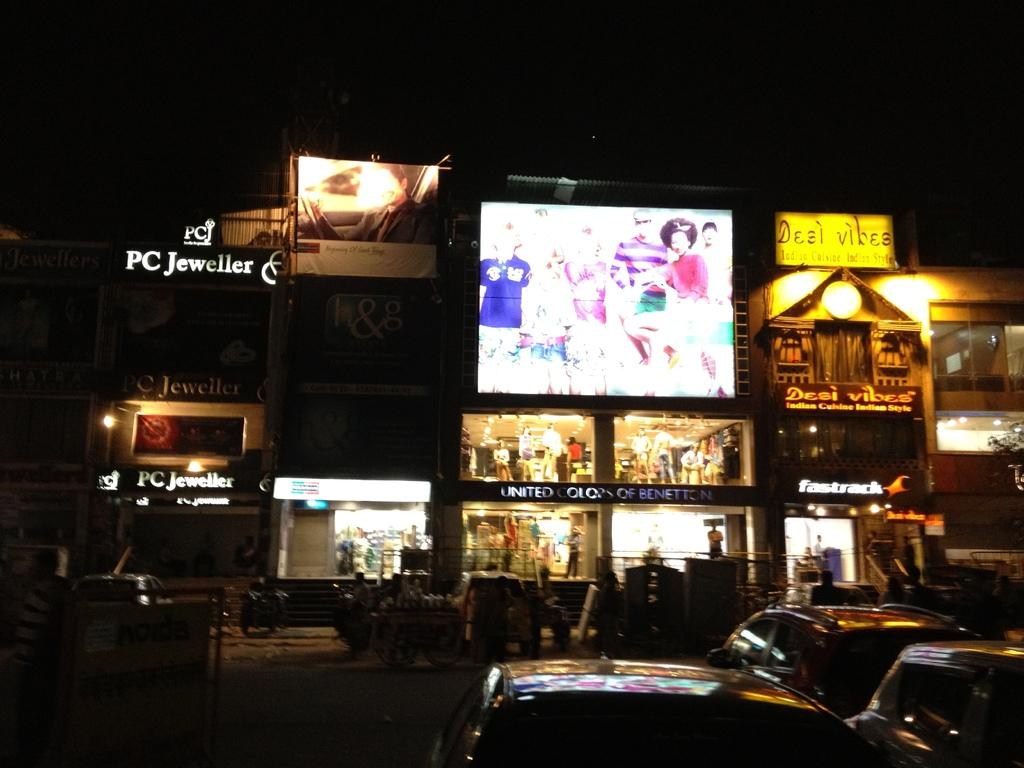<image>
Render a clear and concise summary of the photo. A yellow sign for Desi Vibes hangs next to a brightly lit electronic billboard. 